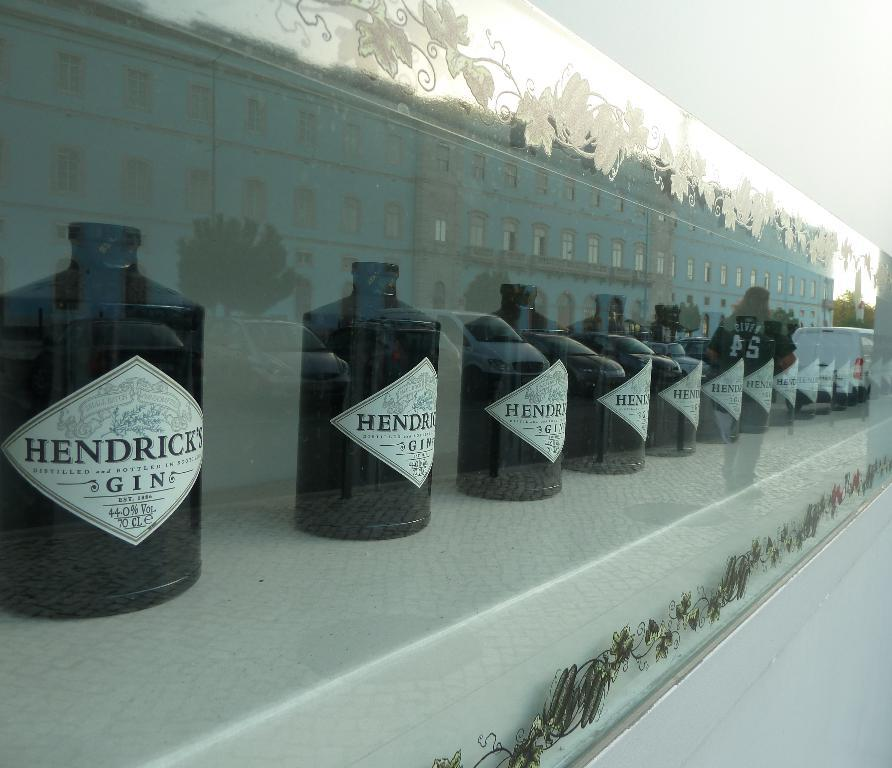<image>
Describe the image concisely. Black bottles that says "Hendricks Gin" on it. 